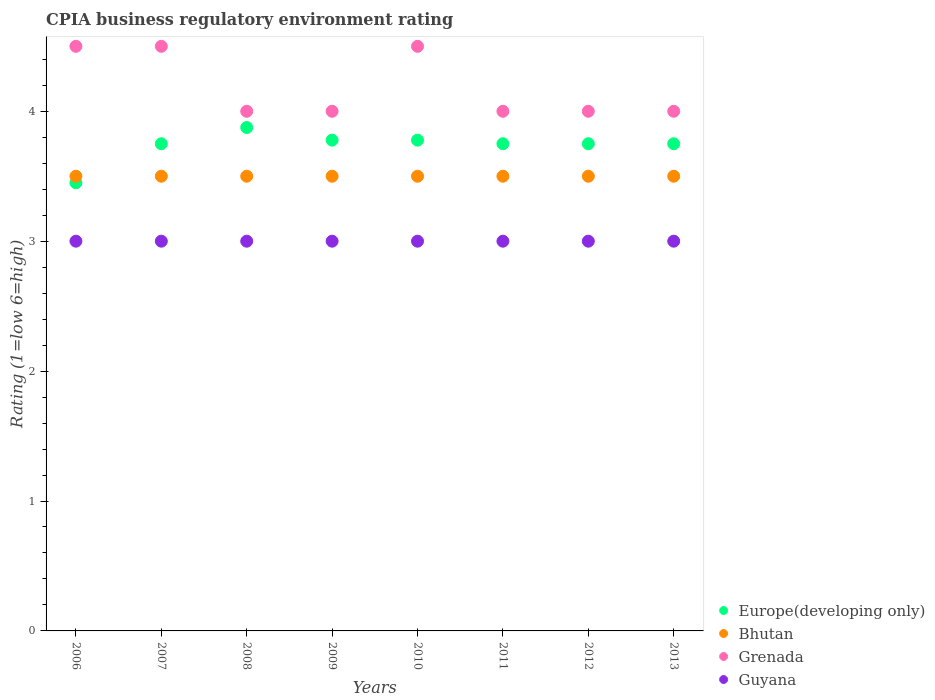Is the number of dotlines equal to the number of legend labels?
Provide a succinct answer. Yes. What is the CPIA rating in Grenada in 2009?
Provide a short and direct response. 4. Across all years, what is the maximum CPIA rating in Guyana?
Your response must be concise. 3. Across all years, what is the minimum CPIA rating in Guyana?
Provide a succinct answer. 3. In which year was the CPIA rating in Europe(developing only) maximum?
Keep it short and to the point. 2008. What is the total CPIA rating in Bhutan in the graph?
Ensure brevity in your answer.  28. What is the difference between the CPIA rating in Bhutan in 2007 and that in 2009?
Make the answer very short. 0. What is the difference between the CPIA rating in Bhutan in 2006 and the CPIA rating in Grenada in 2008?
Make the answer very short. -0.5. What is the average CPIA rating in Europe(developing only) per year?
Offer a terse response. 3.74. What is the ratio of the CPIA rating in Europe(developing only) in 2010 to that in 2012?
Your answer should be compact. 1.01. Is the CPIA rating in Bhutan in 2009 less than that in 2012?
Make the answer very short. No. In how many years, is the CPIA rating in Grenada greater than the average CPIA rating in Grenada taken over all years?
Provide a succinct answer. 3. Is it the case that in every year, the sum of the CPIA rating in Guyana and CPIA rating in Europe(developing only)  is greater than the sum of CPIA rating in Grenada and CPIA rating in Bhutan?
Give a very brief answer. No. Is it the case that in every year, the sum of the CPIA rating in Europe(developing only) and CPIA rating in Guyana  is greater than the CPIA rating in Bhutan?
Provide a succinct answer. Yes. Is the CPIA rating in Grenada strictly greater than the CPIA rating in Europe(developing only) over the years?
Your answer should be very brief. Yes. Is the CPIA rating in Grenada strictly less than the CPIA rating in Guyana over the years?
Provide a succinct answer. No. How many dotlines are there?
Your response must be concise. 4. How many years are there in the graph?
Your answer should be very brief. 8. Where does the legend appear in the graph?
Ensure brevity in your answer.  Bottom right. How many legend labels are there?
Provide a succinct answer. 4. How are the legend labels stacked?
Your response must be concise. Vertical. What is the title of the graph?
Your answer should be compact. CPIA business regulatory environment rating. Does "Ukraine" appear as one of the legend labels in the graph?
Your answer should be compact. No. What is the label or title of the X-axis?
Give a very brief answer. Years. What is the Rating (1=low 6=high) in Europe(developing only) in 2006?
Give a very brief answer. 3.45. What is the Rating (1=low 6=high) of Bhutan in 2006?
Provide a short and direct response. 3.5. What is the Rating (1=low 6=high) of Grenada in 2006?
Your answer should be very brief. 4.5. What is the Rating (1=low 6=high) in Guyana in 2006?
Offer a terse response. 3. What is the Rating (1=low 6=high) of Europe(developing only) in 2007?
Offer a very short reply. 3.75. What is the Rating (1=low 6=high) in Bhutan in 2007?
Offer a very short reply. 3.5. What is the Rating (1=low 6=high) of Grenada in 2007?
Keep it short and to the point. 4.5. What is the Rating (1=low 6=high) of Guyana in 2007?
Provide a succinct answer. 3. What is the Rating (1=low 6=high) in Europe(developing only) in 2008?
Ensure brevity in your answer.  3.88. What is the Rating (1=low 6=high) in Bhutan in 2008?
Offer a terse response. 3.5. What is the Rating (1=low 6=high) in Grenada in 2008?
Your response must be concise. 4. What is the Rating (1=low 6=high) in Guyana in 2008?
Offer a very short reply. 3. What is the Rating (1=low 6=high) in Europe(developing only) in 2009?
Offer a very short reply. 3.78. What is the Rating (1=low 6=high) in Bhutan in 2009?
Provide a short and direct response. 3.5. What is the Rating (1=low 6=high) of Guyana in 2009?
Ensure brevity in your answer.  3. What is the Rating (1=low 6=high) of Europe(developing only) in 2010?
Ensure brevity in your answer.  3.78. What is the Rating (1=low 6=high) of Bhutan in 2010?
Your answer should be compact. 3.5. What is the Rating (1=low 6=high) of Europe(developing only) in 2011?
Your response must be concise. 3.75. What is the Rating (1=low 6=high) of Grenada in 2011?
Your answer should be compact. 4. What is the Rating (1=low 6=high) in Guyana in 2011?
Ensure brevity in your answer.  3. What is the Rating (1=low 6=high) of Europe(developing only) in 2012?
Keep it short and to the point. 3.75. What is the Rating (1=low 6=high) of Bhutan in 2012?
Make the answer very short. 3.5. What is the Rating (1=low 6=high) of Grenada in 2012?
Your response must be concise. 4. What is the Rating (1=low 6=high) of Europe(developing only) in 2013?
Provide a short and direct response. 3.75. What is the Rating (1=low 6=high) in Grenada in 2013?
Your answer should be very brief. 4. What is the Rating (1=low 6=high) in Guyana in 2013?
Give a very brief answer. 3. Across all years, what is the maximum Rating (1=low 6=high) of Europe(developing only)?
Give a very brief answer. 3.88. Across all years, what is the maximum Rating (1=low 6=high) in Grenada?
Your answer should be compact. 4.5. Across all years, what is the maximum Rating (1=low 6=high) in Guyana?
Make the answer very short. 3. Across all years, what is the minimum Rating (1=low 6=high) in Europe(developing only)?
Make the answer very short. 3.45. What is the total Rating (1=low 6=high) of Europe(developing only) in the graph?
Give a very brief answer. 29.88. What is the total Rating (1=low 6=high) of Grenada in the graph?
Your response must be concise. 33.5. What is the total Rating (1=low 6=high) of Guyana in the graph?
Provide a short and direct response. 24. What is the difference between the Rating (1=low 6=high) of Bhutan in 2006 and that in 2007?
Provide a short and direct response. 0. What is the difference between the Rating (1=low 6=high) of Guyana in 2006 and that in 2007?
Offer a very short reply. 0. What is the difference between the Rating (1=low 6=high) in Europe(developing only) in 2006 and that in 2008?
Your answer should be very brief. -0.42. What is the difference between the Rating (1=low 6=high) in Grenada in 2006 and that in 2008?
Give a very brief answer. 0.5. What is the difference between the Rating (1=low 6=high) of Guyana in 2006 and that in 2008?
Give a very brief answer. 0. What is the difference between the Rating (1=low 6=high) of Europe(developing only) in 2006 and that in 2009?
Provide a short and direct response. -0.33. What is the difference between the Rating (1=low 6=high) in Grenada in 2006 and that in 2009?
Offer a terse response. 0.5. What is the difference between the Rating (1=low 6=high) of Europe(developing only) in 2006 and that in 2010?
Provide a short and direct response. -0.33. What is the difference between the Rating (1=low 6=high) in Grenada in 2006 and that in 2010?
Make the answer very short. 0. What is the difference between the Rating (1=low 6=high) in Bhutan in 2006 and that in 2013?
Your answer should be compact. 0. What is the difference between the Rating (1=low 6=high) in Grenada in 2006 and that in 2013?
Your response must be concise. 0.5. What is the difference between the Rating (1=low 6=high) in Guyana in 2006 and that in 2013?
Your answer should be very brief. 0. What is the difference between the Rating (1=low 6=high) in Europe(developing only) in 2007 and that in 2008?
Provide a succinct answer. -0.12. What is the difference between the Rating (1=low 6=high) of Bhutan in 2007 and that in 2008?
Ensure brevity in your answer.  0. What is the difference between the Rating (1=low 6=high) in Grenada in 2007 and that in 2008?
Ensure brevity in your answer.  0.5. What is the difference between the Rating (1=low 6=high) of Europe(developing only) in 2007 and that in 2009?
Your answer should be compact. -0.03. What is the difference between the Rating (1=low 6=high) of Guyana in 2007 and that in 2009?
Your response must be concise. 0. What is the difference between the Rating (1=low 6=high) of Europe(developing only) in 2007 and that in 2010?
Your answer should be very brief. -0.03. What is the difference between the Rating (1=low 6=high) in Bhutan in 2007 and that in 2010?
Your answer should be compact. 0. What is the difference between the Rating (1=low 6=high) in Guyana in 2007 and that in 2010?
Ensure brevity in your answer.  0. What is the difference between the Rating (1=low 6=high) of Grenada in 2007 and that in 2011?
Your answer should be very brief. 0.5. What is the difference between the Rating (1=low 6=high) of Guyana in 2007 and that in 2011?
Offer a very short reply. 0. What is the difference between the Rating (1=low 6=high) of Bhutan in 2007 and that in 2012?
Offer a terse response. 0. What is the difference between the Rating (1=low 6=high) in Guyana in 2007 and that in 2012?
Offer a terse response. 0. What is the difference between the Rating (1=low 6=high) in Europe(developing only) in 2007 and that in 2013?
Offer a terse response. 0. What is the difference between the Rating (1=low 6=high) of Bhutan in 2007 and that in 2013?
Offer a terse response. 0. What is the difference between the Rating (1=low 6=high) in Guyana in 2007 and that in 2013?
Your answer should be compact. 0. What is the difference between the Rating (1=low 6=high) of Europe(developing only) in 2008 and that in 2009?
Offer a terse response. 0.1. What is the difference between the Rating (1=low 6=high) in Guyana in 2008 and that in 2009?
Give a very brief answer. 0. What is the difference between the Rating (1=low 6=high) of Europe(developing only) in 2008 and that in 2010?
Your answer should be compact. 0.1. What is the difference between the Rating (1=low 6=high) in Bhutan in 2008 and that in 2010?
Your answer should be compact. 0. What is the difference between the Rating (1=low 6=high) in Europe(developing only) in 2008 and that in 2011?
Give a very brief answer. 0.12. What is the difference between the Rating (1=low 6=high) of Bhutan in 2008 and that in 2011?
Keep it short and to the point. 0. What is the difference between the Rating (1=low 6=high) in Europe(developing only) in 2008 and that in 2012?
Keep it short and to the point. 0.12. What is the difference between the Rating (1=low 6=high) in Europe(developing only) in 2008 and that in 2013?
Your answer should be very brief. 0.12. What is the difference between the Rating (1=low 6=high) in Guyana in 2008 and that in 2013?
Your response must be concise. 0. What is the difference between the Rating (1=low 6=high) of Europe(developing only) in 2009 and that in 2010?
Provide a succinct answer. 0. What is the difference between the Rating (1=low 6=high) in Bhutan in 2009 and that in 2010?
Your answer should be very brief. 0. What is the difference between the Rating (1=low 6=high) in Europe(developing only) in 2009 and that in 2011?
Give a very brief answer. 0.03. What is the difference between the Rating (1=low 6=high) of Grenada in 2009 and that in 2011?
Offer a terse response. 0. What is the difference between the Rating (1=low 6=high) of Europe(developing only) in 2009 and that in 2012?
Your answer should be compact. 0.03. What is the difference between the Rating (1=low 6=high) of Europe(developing only) in 2009 and that in 2013?
Provide a short and direct response. 0.03. What is the difference between the Rating (1=low 6=high) in Bhutan in 2009 and that in 2013?
Offer a terse response. 0. What is the difference between the Rating (1=low 6=high) of Grenada in 2009 and that in 2013?
Your answer should be compact. 0. What is the difference between the Rating (1=low 6=high) of Europe(developing only) in 2010 and that in 2011?
Your response must be concise. 0.03. What is the difference between the Rating (1=low 6=high) of Bhutan in 2010 and that in 2011?
Keep it short and to the point. 0. What is the difference between the Rating (1=low 6=high) of Guyana in 2010 and that in 2011?
Your response must be concise. 0. What is the difference between the Rating (1=low 6=high) of Europe(developing only) in 2010 and that in 2012?
Give a very brief answer. 0.03. What is the difference between the Rating (1=low 6=high) of Guyana in 2010 and that in 2012?
Provide a succinct answer. 0. What is the difference between the Rating (1=low 6=high) of Europe(developing only) in 2010 and that in 2013?
Your answer should be very brief. 0.03. What is the difference between the Rating (1=low 6=high) in Grenada in 2010 and that in 2013?
Make the answer very short. 0.5. What is the difference between the Rating (1=low 6=high) in Guyana in 2010 and that in 2013?
Your response must be concise. 0. What is the difference between the Rating (1=low 6=high) in Europe(developing only) in 2011 and that in 2012?
Provide a succinct answer. 0. What is the difference between the Rating (1=low 6=high) of Grenada in 2011 and that in 2012?
Your answer should be very brief. 0. What is the difference between the Rating (1=low 6=high) in Guyana in 2011 and that in 2012?
Provide a short and direct response. 0. What is the difference between the Rating (1=low 6=high) in Europe(developing only) in 2011 and that in 2013?
Your response must be concise. 0. What is the difference between the Rating (1=low 6=high) of Bhutan in 2011 and that in 2013?
Ensure brevity in your answer.  0. What is the difference between the Rating (1=low 6=high) in Grenada in 2011 and that in 2013?
Your response must be concise. 0. What is the difference between the Rating (1=low 6=high) of Europe(developing only) in 2012 and that in 2013?
Give a very brief answer. 0. What is the difference between the Rating (1=low 6=high) of Bhutan in 2012 and that in 2013?
Your answer should be compact. 0. What is the difference between the Rating (1=low 6=high) in Grenada in 2012 and that in 2013?
Make the answer very short. 0. What is the difference between the Rating (1=low 6=high) in Europe(developing only) in 2006 and the Rating (1=low 6=high) in Grenada in 2007?
Give a very brief answer. -1.05. What is the difference between the Rating (1=low 6=high) of Europe(developing only) in 2006 and the Rating (1=low 6=high) of Guyana in 2007?
Your answer should be compact. 0.45. What is the difference between the Rating (1=low 6=high) of Bhutan in 2006 and the Rating (1=low 6=high) of Grenada in 2007?
Your answer should be very brief. -1. What is the difference between the Rating (1=low 6=high) in Europe(developing only) in 2006 and the Rating (1=low 6=high) in Grenada in 2008?
Give a very brief answer. -0.55. What is the difference between the Rating (1=low 6=high) of Europe(developing only) in 2006 and the Rating (1=low 6=high) of Guyana in 2008?
Provide a succinct answer. 0.45. What is the difference between the Rating (1=low 6=high) in Bhutan in 2006 and the Rating (1=low 6=high) in Grenada in 2008?
Provide a succinct answer. -0.5. What is the difference between the Rating (1=low 6=high) in Europe(developing only) in 2006 and the Rating (1=low 6=high) in Grenada in 2009?
Your answer should be compact. -0.55. What is the difference between the Rating (1=low 6=high) in Europe(developing only) in 2006 and the Rating (1=low 6=high) in Guyana in 2009?
Your answer should be compact. 0.45. What is the difference between the Rating (1=low 6=high) in Bhutan in 2006 and the Rating (1=low 6=high) in Grenada in 2009?
Keep it short and to the point. -0.5. What is the difference between the Rating (1=low 6=high) of Bhutan in 2006 and the Rating (1=low 6=high) of Guyana in 2009?
Your response must be concise. 0.5. What is the difference between the Rating (1=low 6=high) of Europe(developing only) in 2006 and the Rating (1=low 6=high) of Grenada in 2010?
Your response must be concise. -1.05. What is the difference between the Rating (1=low 6=high) in Europe(developing only) in 2006 and the Rating (1=low 6=high) in Guyana in 2010?
Your answer should be very brief. 0.45. What is the difference between the Rating (1=low 6=high) in Bhutan in 2006 and the Rating (1=low 6=high) in Grenada in 2010?
Ensure brevity in your answer.  -1. What is the difference between the Rating (1=low 6=high) of Grenada in 2006 and the Rating (1=low 6=high) of Guyana in 2010?
Your answer should be very brief. 1.5. What is the difference between the Rating (1=low 6=high) of Europe(developing only) in 2006 and the Rating (1=low 6=high) of Bhutan in 2011?
Offer a very short reply. -0.05. What is the difference between the Rating (1=low 6=high) of Europe(developing only) in 2006 and the Rating (1=low 6=high) of Grenada in 2011?
Your answer should be very brief. -0.55. What is the difference between the Rating (1=low 6=high) of Europe(developing only) in 2006 and the Rating (1=low 6=high) of Guyana in 2011?
Provide a succinct answer. 0.45. What is the difference between the Rating (1=low 6=high) in Bhutan in 2006 and the Rating (1=low 6=high) in Grenada in 2011?
Your response must be concise. -0.5. What is the difference between the Rating (1=low 6=high) of Bhutan in 2006 and the Rating (1=low 6=high) of Guyana in 2011?
Give a very brief answer. 0.5. What is the difference between the Rating (1=low 6=high) of Grenada in 2006 and the Rating (1=low 6=high) of Guyana in 2011?
Your answer should be very brief. 1.5. What is the difference between the Rating (1=low 6=high) of Europe(developing only) in 2006 and the Rating (1=low 6=high) of Grenada in 2012?
Keep it short and to the point. -0.55. What is the difference between the Rating (1=low 6=high) of Europe(developing only) in 2006 and the Rating (1=low 6=high) of Guyana in 2012?
Ensure brevity in your answer.  0.45. What is the difference between the Rating (1=low 6=high) in Grenada in 2006 and the Rating (1=low 6=high) in Guyana in 2012?
Your answer should be very brief. 1.5. What is the difference between the Rating (1=low 6=high) in Europe(developing only) in 2006 and the Rating (1=low 6=high) in Grenada in 2013?
Ensure brevity in your answer.  -0.55. What is the difference between the Rating (1=low 6=high) in Europe(developing only) in 2006 and the Rating (1=low 6=high) in Guyana in 2013?
Provide a short and direct response. 0.45. What is the difference between the Rating (1=low 6=high) in Bhutan in 2006 and the Rating (1=low 6=high) in Grenada in 2013?
Make the answer very short. -0.5. What is the difference between the Rating (1=low 6=high) of Bhutan in 2006 and the Rating (1=low 6=high) of Guyana in 2013?
Provide a short and direct response. 0.5. What is the difference between the Rating (1=low 6=high) in Grenada in 2006 and the Rating (1=low 6=high) in Guyana in 2013?
Your answer should be very brief. 1.5. What is the difference between the Rating (1=low 6=high) of Europe(developing only) in 2007 and the Rating (1=low 6=high) of Bhutan in 2008?
Ensure brevity in your answer.  0.25. What is the difference between the Rating (1=low 6=high) in Europe(developing only) in 2007 and the Rating (1=low 6=high) in Guyana in 2008?
Keep it short and to the point. 0.75. What is the difference between the Rating (1=low 6=high) of Bhutan in 2007 and the Rating (1=low 6=high) of Grenada in 2008?
Provide a succinct answer. -0.5. What is the difference between the Rating (1=low 6=high) of Europe(developing only) in 2007 and the Rating (1=low 6=high) of Bhutan in 2009?
Offer a very short reply. 0.25. What is the difference between the Rating (1=low 6=high) of Europe(developing only) in 2007 and the Rating (1=low 6=high) of Grenada in 2009?
Your answer should be compact. -0.25. What is the difference between the Rating (1=low 6=high) in Europe(developing only) in 2007 and the Rating (1=low 6=high) in Bhutan in 2010?
Ensure brevity in your answer.  0.25. What is the difference between the Rating (1=low 6=high) in Europe(developing only) in 2007 and the Rating (1=low 6=high) in Grenada in 2010?
Offer a terse response. -0.75. What is the difference between the Rating (1=low 6=high) in Bhutan in 2007 and the Rating (1=low 6=high) in Grenada in 2010?
Keep it short and to the point. -1. What is the difference between the Rating (1=low 6=high) of Bhutan in 2007 and the Rating (1=low 6=high) of Guyana in 2010?
Ensure brevity in your answer.  0.5. What is the difference between the Rating (1=low 6=high) in Europe(developing only) in 2007 and the Rating (1=low 6=high) in Bhutan in 2011?
Your response must be concise. 0.25. What is the difference between the Rating (1=low 6=high) of Europe(developing only) in 2007 and the Rating (1=low 6=high) of Guyana in 2011?
Make the answer very short. 0.75. What is the difference between the Rating (1=low 6=high) in Europe(developing only) in 2007 and the Rating (1=low 6=high) in Grenada in 2012?
Give a very brief answer. -0.25. What is the difference between the Rating (1=low 6=high) in Bhutan in 2007 and the Rating (1=low 6=high) in Grenada in 2012?
Ensure brevity in your answer.  -0.5. What is the difference between the Rating (1=low 6=high) in Europe(developing only) in 2007 and the Rating (1=low 6=high) in Bhutan in 2013?
Offer a terse response. 0.25. What is the difference between the Rating (1=low 6=high) of Europe(developing only) in 2007 and the Rating (1=low 6=high) of Grenada in 2013?
Provide a short and direct response. -0.25. What is the difference between the Rating (1=low 6=high) in Bhutan in 2007 and the Rating (1=low 6=high) in Grenada in 2013?
Your answer should be very brief. -0.5. What is the difference between the Rating (1=low 6=high) in Grenada in 2007 and the Rating (1=low 6=high) in Guyana in 2013?
Ensure brevity in your answer.  1.5. What is the difference between the Rating (1=low 6=high) in Europe(developing only) in 2008 and the Rating (1=low 6=high) in Grenada in 2009?
Give a very brief answer. -0.12. What is the difference between the Rating (1=low 6=high) of Europe(developing only) in 2008 and the Rating (1=low 6=high) of Guyana in 2009?
Your response must be concise. 0.88. What is the difference between the Rating (1=low 6=high) of Bhutan in 2008 and the Rating (1=low 6=high) of Guyana in 2009?
Your answer should be very brief. 0.5. What is the difference between the Rating (1=low 6=high) of Europe(developing only) in 2008 and the Rating (1=low 6=high) of Grenada in 2010?
Ensure brevity in your answer.  -0.62. What is the difference between the Rating (1=low 6=high) in Bhutan in 2008 and the Rating (1=low 6=high) in Grenada in 2010?
Offer a terse response. -1. What is the difference between the Rating (1=low 6=high) in Bhutan in 2008 and the Rating (1=low 6=high) in Guyana in 2010?
Provide a short and direct response. 0.5. What is the difference between the Rating (1=low 6=high) of Europe(developing only) in 2008 and the Rating (1=low 6=high) of Grenada in 2011?
Provide a succinct answer. -0.12. What is the difference between the Rating (1=low 6=high) of Europe(developing only) in 2008 and the Rating (1=low 6=high) of Guyana in 2011?
Provide a succinct answer. 0.88. What is the difference between the Rating (1=low 6=high) in Bhutan in 2008 and the Rating (1=low 6=high) in Guyana in 2011?
Give a very brief answer. 0.5. What is the difference between the Rating (1=low 6=high) in Grenada in 2008 and the Rating (1=low 6=high) in Guyana in 2011?
Ensure brevity in your answer.  1. What is the difference between the Rating (1=low 6=high) of Europe(developing only) in 2008 and the Rating (1=low 6=high) of Grenada in 2012?
Provide a short and direct response. -0.12. What is the difference between the Rating (1=low 6=high) in Europe(developing only) in 2008 and the Rating (1=low 6=high) in Guyana in 2012?
Offer a very short reply. 0.88. What is the difference between the Rating (1=low 6=high) in Grenada in 2008 and the Rating (1=low 6=high) in Guyana in 2012?
Make the answer very short. 1. What is the difference between the Rating (1=low 6=high) in Europe(developing only) in 2008 and the Rating (1=low 6=high) in Bhutan in 2013?
Keep it short and to the point. 0.38. What is the difference between the Rating (1=low 6=high) in Europe(developing only) in 2008 and the Rating (1=low 6=high) in Grenada in 2013?
Make the answer very short. -0.12. What is the difference between the Rating (1=low 6=high) of Europe(developing only) in 2008 and the Rating (1=low 6=high) of Guyana in 2013?
Your answer should be compact. 0.88. What is the difference between the Rating (1=low 6=high) in Bhutan in 2008 and the Rating (1=low 6=high) in Grenada in 2013?
Your answer should be very brief. -0.5. What is the difference between the Rating (1=low 6=high) in Bhutan in 2008 and the Rating (1=low 6=high) in Guyana in 2013?
Provide a succinct answer. 0.5. What is the difference between the Rating (1=low 6=high) in Grenada in 2008 and the Rating (1=low 6=high) in Guyana in 2013?
Your answer should be very brief. 1. What is the difference between the Rating (1=low 6=high) in Europe(developing only) in 2009 and the Rating (1=low 6=high) in Bhutan in 2010?
Provide a short and direct response. 0.28. What is the difference between the Rating (1=low 6=high) of Europe(developing only) in 2009 and the Rating (1=low 6=high) of Grenada in 2010?
Ensure brevity in your answer.  -0.72. What is the difference between the Rating (1=low 6=high) of Bhutan in 2009 and the Rating (1=low 6=high) of Grenada in 2010?
Make the answer very short. -1. What is the difference between the Rating (1=low 6=high) in Europe(developing only) in 2009 and the Rating (1=low 6=high) in Bhutan in 2011?
Your response must be concise. 0.28. What is the difference between the Rating (1=low 6=high) in Europe(developing only) in 2009 and the Rating (1=low 6=high) in Grenada in 2011?
Make the answer very short. -0.22. What is the difference between the Rating (1=low 6=high) of Bhutan in 2009 and the Rating (1=low 6=high) of Grenada in 2011?
Offer a terse response. -0.5. What is the difference between the Rating (1=low 6=high) in Europe(developing only) in 2009 and the Rating (1=low 6=high) in Bhutan in 2012?
Offer a very short reply. 0.28. What is the difference between the Rating (1=low 6=high) in Europe(developing only) in 2009 and the Rating (1=low 6=high) in Grenada in 2012?
Your answer should be compact. -0.22. What is the difference between the Rating (1=low 6=high) of Bhutan in 2009 and the Rating (1=low 6=high) of Grenada in 2012?
Offer a terse response. -0.5. What is the difference between the Rating (1=low 6=high) of Europe(developing only) in 2009 and the Rating (1=low 6=high) of Bhutan in 2013?
Give a very brief answer. 0.28. What is the difference between the Rating (1=low 6=high) of Europe(developing only) in 2009 and the Rating (1=low 6=high) of Grenada in 2013?
Make the answer very short. -0.22. What is the difference between the Rating (1=low 6=high) of Europe(developing only) in 2009 and the Rating (1=low 6=high) of Guyana in 2013?
Your answer should be very brief. 0.78. What is the difference between the Rating (1=low 6=high) of Bhutan in 2009 and the Rating (1=low 6=high) of Guyana in 2013?
Your answer should be compact. 0.5. What is the difference between the Rating (1=low 6=high) in Europe(developing only) in 2010 and the Rating (1=low 6=high) in Bhutan in 2011?
Offer a terse response. 0.28. What is the difference between the Rating (1=low 6=high) of Europe(developing only) in 2010 and the Rating (1=low 6=high) of Grenada in 2011?
Offer a terse response. -0.22. What is the difference between the Rating (1=low 6=high) in Europe(developing only) in 2010 and the Rating (1=low 6=high) in Guyana in 2011?
Give a very brief answer. 0.78. What is the difference between the Rating (1=low 6=high) of Bhutan in 2010 and the Rating (1=low 6=high) of Guyana in 2011?
Make the answer very short. 0.5. What is the difference between the Rating (1=low 6=high) of Europe(developing only) in 2010 and the Rating (1=low 6=high) of Bhutan in 2012?
Offer a very short reply. 0.28. What is the difference between the Rating (1=low 6=high) of Europe(developing only) in 2010 and the Rating (1=low 6=high) of Grenada in 2012?
Your answer should be compact. -0.22. What is the difference between the Rating (1=low 6=high) of Europe(developing only) in 2010 and the Rating (1=low 6=high) of Guyana in 2012?
Keep it short and to the point. 0.78. What is the difference between the Rating (1=low 6=high) in Bhutan in 2010 and the Rating (1=low 6=high) in Grenada in 2012?
Provide a succinct answer. -0.5. What is the difference between the Rating (1=low 6=high) of Europe(developing only) in 2010 and the Rating (1=low 6=high) of Bhutan in 2013?
Ensure brevity in your answer.  0.28. What is the difference between the Rating (1=low 6=high) in Europe(developing only) in 2010 and the Rating (1=low 6=high) in Grenada in 2013?
Provide a short and direct response. -0.22. What is the difference between the Rating (1=low 6=high) in Grenada in 2010 and the Rating (1=low 6=high) in Guyana in 2013?
Ensure brevity in your answer.  1.5. What is the difference between the Rating (1=low 6=high) of Bhutan in 2011 and the Rating (1=low 6=high) of Grenada in 2012?
Your response must be concise. -0.5. What is the difference between the Rating (1=low 6=high) of Europe(developing only) in 2011 and the Rating (1=low 6=high) of Bhutan in 2013?
Provide a short and direct response. 0.25. What is the difference between the Rating (1=low 6=high) in Europe(developing only) in 2011 and the Rating (1=low 6=high) in Grenada in 2013?
Provide a short and direct response. -0.25. What is the difference between the Rating (1=low 6=high) in Europe(developing only) in 2011 and the Rating (1=low 6=high) in Guyana in 2013?
Give a very brief answer. 0.75. What is the difference between the Rating (1=low 6=high) of Bhutan in 2011 and the Rating (1=low 6=high) of Grenada in 2013?
Offer a terse response. -0.5. What is the difference between the Rating (1=low 6=high) in Bhutan in 2011 and the Rating (1=low 6=high) in Guyana in 2013?
Your response must be concise. 0.5. What is the difference between the Rating (1=low 6=high) of Europe(developing only) in 2012 and the Rating (1=low 6=high) of Bhutan in 2013?
Make the answer very short. 0.25. What is the difference between the Rating (1=low 6=high) of Europe(developing only) in 2012 and the Rating (1=low 6=high) of Grenada in 2013?
Your response must be concise. -0.25. What is the difference between the Rating (1=low 6=high) of Bhutan in 2012 and the Rating (1=low 6=high) of Grenada in 2013?
Keep it short and to the point. -0.5. What is the average Rating (1=low 6=high) of Europe(developing only) per year?
Your response must be concise. 3.74. What is the average Rating (1=low 6=high) in Bhutan per year?
Offer a very short reply. 3.5. What is the average Rating (1=low 6=high) in Grenada per year?
Offer a very short reply. 4.19. What is the average Rating (1=low 6=high) of Guyana per year?
Keep it short and to the point. 3. In the year 2006, what is the difference between the Rating (1=low 6=high) in Europe(developing only) and Rating (1=low 6=high) in Bhutan?
Your answer should be compact. -0.05. In the year 2006, what is the difference between the Rating (1=low 6=high) of Europe(developing only) and Rating (1=low 6=high) of Grenada?
Make the answer very short. -1.05. In the year 2006, what is the difference between the Rating (1=low 6=high) in Europe(developing only) and Rating (1=low 6=high) in Guyana?
Your response must be concise. 0.45. In the year 2006, what is the difference between the Rating (1=low 6=high) in Bhutan and Rating (1=low 6=high) in Grenada?
Provide a short and direct response. -1. In the year 2006, what is the difference between the Rating (1=low 6=high) in Bhutan and Rating (1=low 6=high) in Guyana?
Provide a short and direct response. 0.5. In the year 2006, what is the difference between the Rating (1=low 6=high) of Grenada and Rating (1=low 6=high) of Guyana?
Ensure brevity in your answer.  1.5. In the year 2007, what is the difference between the Rating (1=low 6=high) in Europe(developing only) and Rating (1=low 6=high) in Grenada?
Ensure brevity in your answer.  -0.75. In the year 2007, what is the difference between the Rating (1=low 6=high) of Bhutan and Rating (1=low 6=high) of Grenada?
Offer a terse response. -1. In the year 2007, what is the difference between the Rating (1=low 6=high) of Bhutan and Rating (1=low 6=high) of Guyana?
Offer a very short reply. 0.5. In the year 2008, what is the difference between the Rating (1=low 6=high) of Europe(developing only) and Rating (1=low 6=high) of Bhutan?
Provide a succinct answer. 0.38. In the year 2008, what is the difference between the Rating (1=low 6=high) in Europe(developing only) and Rating (1=low 6=high) in Grenada?
Provide a succinct answer. -0.12. In the year 2008, what is the difference between the Rating (1=low 6=high) of Europe(developing only) and Rating (1=low 6=high) of Guyana?
Offer a very short reply. 0.88. In the year 2008, what is the difference between the Rating (1=low 6=high) of Bhutan and Rating (1=low 6=high) of Grenada?
Your answer should be compact. -0.5. In the year 2008, what is the difference between the Rating (1=low 6=high) in Bhutan and Rating (1=low 6=high) in Guyana?
Make the answer very short. 0.5. In the year 2009, what is the difference between the Rating (1=low 6=high) of Europe(developing only) and Rating (1=low 6=high) of Bhutan?
Provide a succinct answer. 0.28. In the year 2009, what is the difference between the Rating (1=low 6=high) in Europe(developing only) and Rating (1=low 6=high) in Grenada?
Offer a terse response. -0.22. In the year 2009, what is the difference between the Rating (1=low 6=high) in Grenada and Rating (1=low 6=high) in Guyana?
Provide a succinct answer. 1. In the year 2010, what is the difference between the Rating (1=low 6=high) in Europe(developing only) and Rating (1=low 6=high) in Bhutan?
Your response must be concise. 0.28. In the year 2010, what is the difference between the Rating (1=low 6=high) in Europe(developing only) and Rating (1=low 6=high) in Grenada?
Ensure brevity in your answer.  -0.72. In the year 2010, what is the difference between the Rating (1=low 6=high) of Europe(developing only) and Rating (1=low 6=high) of Guyana?
Provide a short and direct response. 0.78. In the year 2010, what is the difference between the Rating (1=low 6=high) in Bhutan and Rating (1=low 6=high) in Guyana?
Ensure brevity in your answer.  0.5. In the year 2011, what is the difference between the Rating (1=low 6=high) of Bhutan and Rating (1=low 6=high) of Grenada?
Keep it short and to the point. -0.5. In the year 2011, what is the difference between the Rating (1=low 6=high) in Grenada and Rating (1=low 6=high) in Guyana?
Give a very brief answer. 1. In the year 2012, what is the difference between the Rating (1=low 6=high) in Europe(developing only) and Rating (1=low 6=high) in Bhutan?
Give a very brief answer. 0.25. In the year 2012, what is the difference between the Rating (1=low 6=high) of Bhutan and Rating (1=low 6=high) of Guyana?
Offer a terse response. 0.5. In the year 2012, what is the difference between the Rating (1=low 6=high) in Grenada and Rating (1=low 6=high) in Guyana?
Your answer should be very brief. 1. In the year 2013, what is the difference between the Rating (1=low 6=high) of Europe(developing only) and Rating (1=low 6=high) of Grenada?
Provide a short and direct response. -0.25. In the year 2013, what is the difference between the Rating (1=low 6=high) of Bhutan and Rating (1=low 6=high) of Grenada?
Make the answer very short. -0.5. In the year 2013, what is the difference between the Rating (1=low 6=high) in Bhutan and Rating (1=low 6=high) in Guyana?
Give a very brief answer. 0.5. In the year 2013, what is the difference between the Rating (1=low 6=high) in Grenada and Rating (1=low 6=high) in Guyana?
Your answer should be very brief. 1. What is the ratio of the Rating (1=low 6=high) in Europe(developing only) in 2006 to that in 2007?
Your answer should be compact. 0.92. What is the ratio of the Rating (1=low 6=high) of Europe(developing only) in 2006 to that in 2008?
Provide a succinct answer. 0.89. What is the ratio of the Rating (1=low 6=high) of Grenada in 2006 to that in 2008?
Provide a succinct answer. 1.12. What is the ratio of the Rating (1=low 6=high) of Europe(developing only) in 2006 to that in 2009?
Provide a succinct answer. 0.91. What is the ratio of the Rating (1=low 6=high) of Bhutan in 2006 to that in 2009?
Offer a terse response. 1. What is the ratio of the Rating (1=low 6=high) in Europe(developing only) in 2006 to that in 2010?
Keep it short and to the point. 0.91. What is the ratio of the Rating (1=low 6=high) of Grenada in 2006 to that in 2010?
Your response must be concise. 1. What is the ratio of the Rating (1=low 6=high) of Guyana in 2006 to that in 2010?
Make the answer very short. 1. What is the ratio of the Rating (1=low 6=high) in Europe(developing only) in 2006 to that in 2011?
Keep it short and to the point. 0.92. What is the ratio of the Rating (1=low 6=high) in Grenada in 2006 to that in 2012?
Provide a short and direct response. 1.12. What is the ratio of the Rating (1=low 6=high) of Guyana in 2006 to that in 2012?
Offer a terse response. 1. What is the ratio of the Rating (1=low 6=high) in Europe(developing only) in 2006 to that in 2013?
Provide a succinct answer. 0.92. What is the ratio of the Rating (1=low 6=high) of Bhutan in 2006 to that in 2013?
Offer a very short reply. 1. What is the ratio of the Rating (1=low 6=high) of Guyana in 2006 to that in 2013?
Give a very brief answer. 1. What is the ratio of the Rating (1=low 6=high) of Grenada in 2007 to that in 2008?
Your response must be concise. 1.12. What is the ratio of the Rating (1=low 6=high) of Bhutan in 2007 to that in 2009?
Your answer should be very brief. 1. What is the ratio of the Rating (1=low 6=high) of Grenada in 2007 to that in 2009?
Provide a succinct answer. 1.12. What is the ratio of the Rating (1=low 6=high) of Grenada in 2007 to that in 2010?
Ensure brevity in your answer.  1. What is the ratio of the Rating (1=low 6=high) in Guyana in 2007 to that in 2010?
Offer a terse response. 1. What is the ratio of the Rating (1=low 6=high) of Europe(developing only) in 2007 to that in 2011?
Provide a succinct answer. 1. What is the ratio of the Rating (1=low 6=high) of Bhutan in 2007 to that in 2011?
Ensure brevity in your answer.  1. What is the ratio of the Rating (1=low 6=high) in Bhutan in 2007 to that in 2012?
Your answer should be very brief. 1. What is the ratio of the Rating (1=low 6=high) in Guyana in 2007 to that in 2012?
Offer a very short reply. 1. What is the ratio of the Rating (1=low 6=high) in Europe(developing only) in 2007 to that in 2013?
Your answer should be compact. 1. What is the ratio of the Rating (1=low 6=high) of Bhutan in 2007 to that in 2013?
Ensure brevity in your answer.  1. What is the ratio of the Rating (1=low 6=high) in Grenada in 2007 to that in 2013?
Your answer should be compact. 1.12. What is the ratio of the Rating (1=low 6=high) of Europe(developing only) in 2008 to that in 2009?
Your answer should be very brief. 1.03. What is the ratio of the Rating (1=low 6=high) in Grenada in 2008 to that in 2009?
Your answer should be compact. 1. What is the ratio of the Rating (1=low 6=high) in Guyana in 2008 to that in 2009?
Your answer should be very brief. 1. What is the ratio of the Rating (1=low 6=high) in Europe(developing only) in 2008 to that in 2010?
Your answer should be compact. 1.03. What is the ratio of the Rating (1=low 6=high) of Grenada in 2008 to that in 2010?
Provide a short and direct response. 0.89. What is the ratio of the Rating (1=low 6=high) of Europe(developing only) in 2008 to that in 2011?
Provide a short and direct response. 1.03. What is the ratio of the Rating (1=low 6=high) of Bhutan in 2008 to that in 2011?
Your answer should be compact. 1. What is the ratio of the Rating (1=low 6=high) in Guyana in 2008 to that in 2011?
Provide a short and direct response. 1. What is the ratio of the Rating (1=low 6=high) in Europe(developing only) in 2008 to that in 2012?
Your answer should be very brief. 1.03. What is the ratio of the Rating (1=low 6=high) in Grenada in 2008 to that in 2012?
Provide a succinct answer. 1. What is the ratio of the Rating (1=low 6=high) of Europe(developing only) in 2008 to that in 2013?
Offer a terse response. 1.03. What is the ratio of the Rating (1=low 6=high) in Bhutan in 2008 to that in 2013?
Your answer should be very brief. 1. What is the ratio of the Rating (1=low 6=high) in Guyana in 2008 to that in 2013?
Ensure brevity in your answer.  1. What is the ratio of the Rating (1=low 6=high) of Bhutan in 2009 to that in 2010?
Ensure brevity in your answer.  1. What is the ratio of the Rating (1=low 6=high) in Grenada in 2009 to that in 2010?
Offer a terse response. 0.89. What is the ratio of the Rating (1=low 6=high) of Guyana in 2009 to that in 2010?
Provide a short and direct response. 1. What is the ratio of the Rating (1=low 6=high) in Europe(developing only) in 2009 to that in 2011?
Your response must be concise. 1.01. What is the ratio of the Rating (1=low 6=high) in Bhutan in 2009 to that in 2011?
Provide a succinct answer. 1. What is the ratio of the Rating (1=low 6=high) in Guyana in 2009 to that in 2011?
Give a very brief answer. 1. What is the ratio of the Rating (1=low 6=high) in Europe(developing only) in 2009 to that in 2012?
Provide a succinct answer. 1.01. What is the ratio of the Rating (1=low 6=high) of Guyana in 2009 to that in 2012?
Ensure brevity in your answer.  1. What is the ratio of the Rating (1=low 6=high) in Europe(developing only) in 2009 to that in 2013?
Keep it short and to the point. 1.01. What is the ratio of the Rating (1=low 6=high) of Bhutan in 2009 to that in 2013?
Offer a terse response. 1. What is the ratio of the Rating (1=low 6=high) in Grenada in 2009 to that in 2013?
Offer a very short reply. 1. What is the ratio of the Rating (1=low 6=high) of Guyana in 2009 to that in 2013?
Provide a succinct answer. 1. What is the ratio of the Rating (1=low 6=high) of Europe(developing only) in 2010 to that in 2011?
Your answer should be very brief. 1.01. What is the ratio of the Rating (1=low 6=high) in Bhutan in 2010 to that in 2011?
Give a very brief answer. 1. What is the ratio of the Rating (1=low 6=high) in Europe(developing only) in 2010 to that in 2012?
Ensure brevity in your answer.  1.01. What is the ratio of the Rating (1=low 6=high) in Guyana in 2010 to that in 2012?
Make the answer very short. 1. What is the ratio of the Rating (1=low 6=high) in Europe(developing only) in 2010 to that in 2013?
Provide a succinct answer. 1.01. What is the ratio of the Rating (1=low 6=high) of Bhutan in 2010 to that in 2013?
Your answer should be compact. 1. What is the ratio of the Rating (1=low 6=high) of Europe(developing only) in 2011 to that in 2012?
Your response must be concise. 1. What is the ratio of the Rating (1=low 6=high) in Bhutan in 2011 to that in 2012?
Your answer should be very brief. 1. What is the ratio of the Rating (1=low 6=high) in Bhutan in 2011 to that in 2013?
Keep it short and to the point. 1. What is the ratio of the Rating (1=low 6=high) of Grenada in 2011 to that in 2013?
Keep it short and to the point. 1. What is the ratio of the Rating (1=low 6=high) of Bhutan in 2012 to that in 2013?
Ensure brevity in your answer.  1. What is the ratio of the Rating (1=low 6=high) of Grenada in 2012 to that in 2013?
Your answer should be very brief. 1. What is the ratio of the Rating (1=low 6=high) of Guyana in 2012 to that in 2013?
Give a very brief answer. 1. What is the difference between the highest and the second highest Rating (1=low 6=high) in Europe(developing only)?
Keep it short and to the point. 0.1. What is the difference between the highest and the second highest Rating (1=low 6=high) in Grenada?
Offer a terse response. 0. What is the difference between the highest and the lowest Rating (1=low 6=high) of Europe(developing only)?
Keep it short and to the point. 0.42. What is the difference between the highest and the lowest Rating (1=low 6=high) in Bhutan?
Offer a very short reply. 0. What is the difference between the highest and the lowest Rating (1=low 6=high) of Grenada?
Offer a very short reply. 0.5. What is the difference between the highest and the lowest Rating (1=low 6=high) of Guyana?
Your answer should be very brief. 0. 